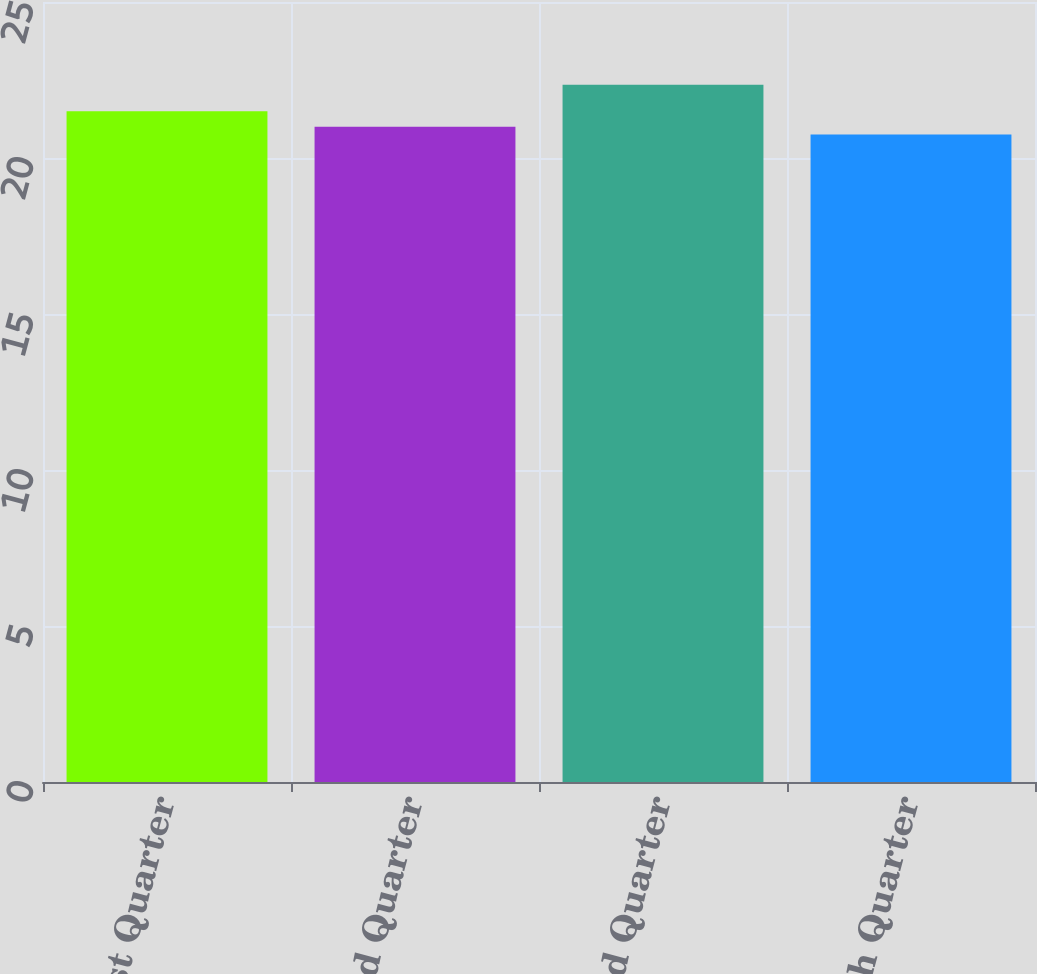Convert chart. <chart><loc_0><loc_0><loc_500><loc_500><bar_chart><fcel>1st Quarter<fcel>2nd Quarter<fcel>3rd Quarter<fcel>4th Quarter<nl><fcel>21.5<fcel>21<fcel>22.35<fcel>20.75<nl></chart> 